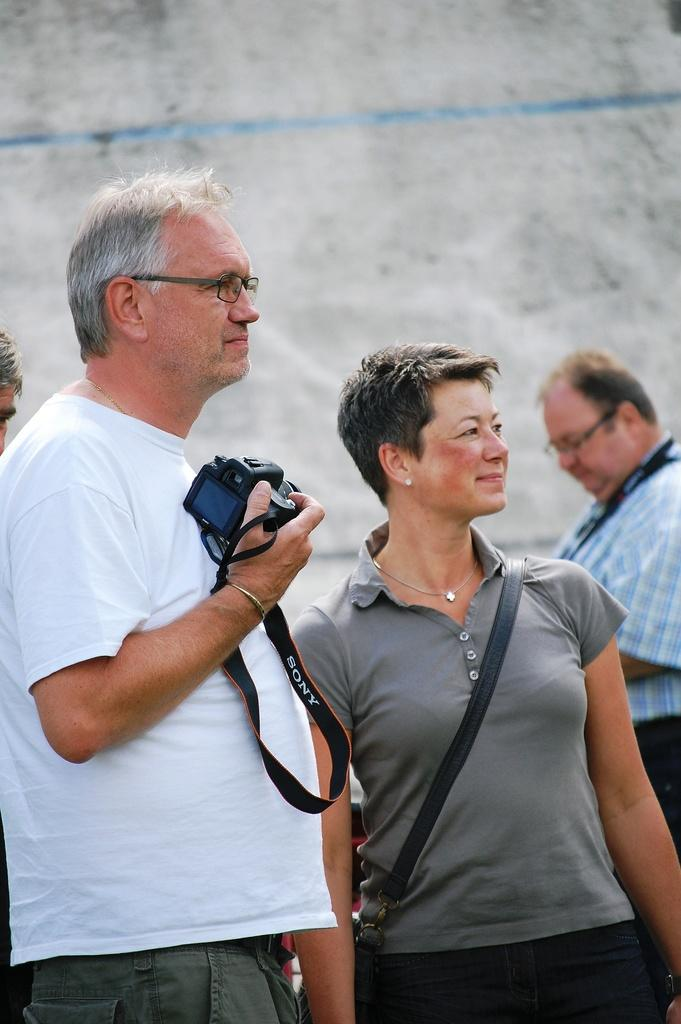How many people are in the image? There are four people in the image. What is one of the people doing in the image? A man is holding a camera in his hand. Can you describe the woman in the image? A woman is present in the image, and she is wearing a handbag. What type of theory is the woman discussing with the geese in the image? There are no geese present in the image, and the woman is not discussing any theories. 